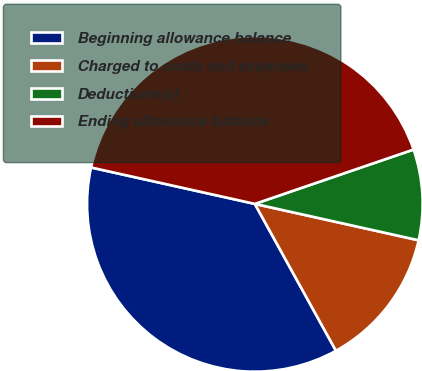Convert chart. <chart><loc_0><loc_0><loc_500><loc_500><pie_chart><fcel>Beginning allowance balance<fcel>Charged to costs and expenses<fcel>Deductions(a)<fcel>Ending allowance balance<nl><fcel>36.51%<fcel>13.49%<fcel>8.73%<fcel>41.27%<nl></chart> 